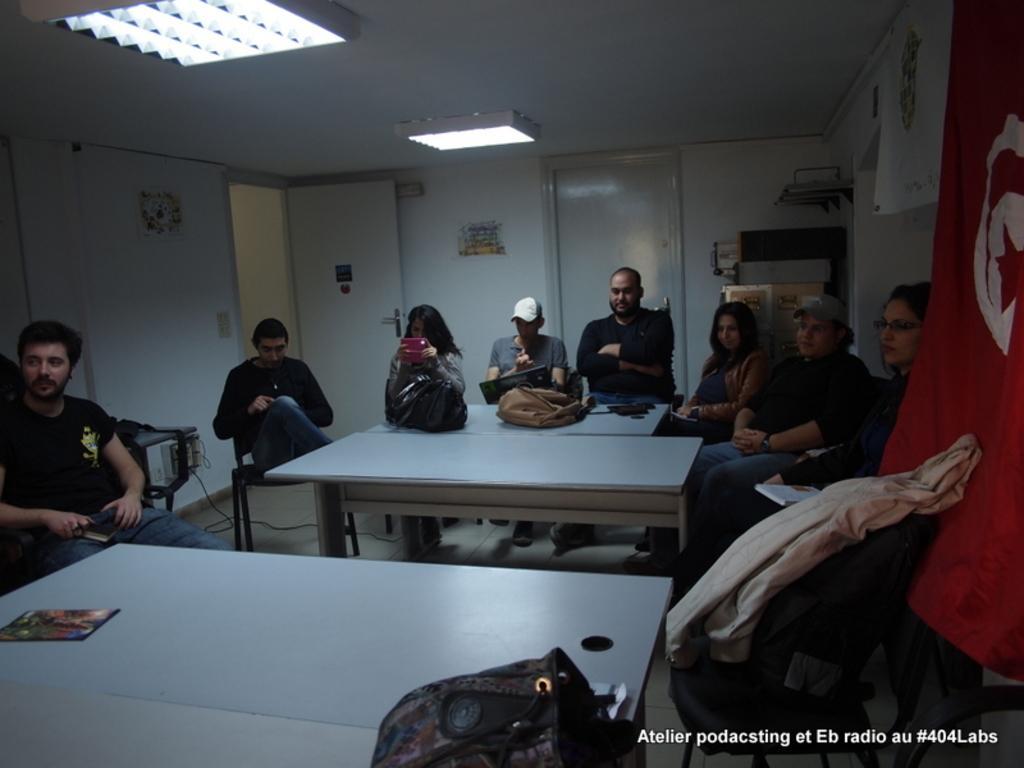Describe this image in one or two sentences. In this image there are group of person sitting on a chair woman sitting on a right side is having a book in her lap, the person sitting in a center is wearing a white colour hat. On the left side woman is holding a phone in her hand. In the background there is a poster attached to the wall , and a door closed and a door is opened. In the center there are tables bags are kept on the table the right side there is a red colour flag and in front of the flag there is a bag and a jacket kept on the chair i can see a bag right in the front of this table kept on this table. 